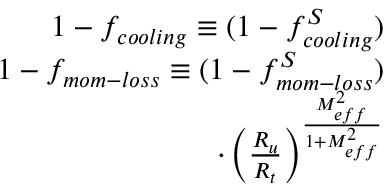<formula> <loc_0><loc_0><loc_500><loc_500>\begin{array} { r } { 1 - f _ { c o o l i n g } \equiv ( 1 - f _ { c o o l i n g } ^ { S } ) } \\ { 1 - f _ { m o m - l o s s } \equiv ( 1 - f _ { m o m - l o s s } ^ { S } ) } \\ { \cdot \left ( \frac { R _ { u } } { R _ { t } } \right ) ^ { \frac { M _ { e f f } ^ { 2 } } { 1 + M _ { e f f } ^ { 2 } } } } \end{array}</formula> 